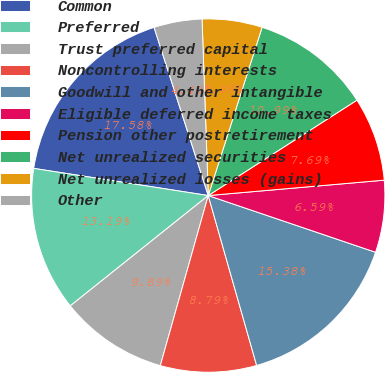<chart> <loc_0><loc_0><loc_500><loc_500><pie_chart><fcel>Common<fcel>Preferred<fcel>Trust preferred capital<fcel>Noncontrolling interests<fcel>Goodwill and other intangible<fcel>Eligible deferred income taxes<fcel>Pension other postretirement<fcel>Net unrealized securities<fcel>Net unrealized losses (gains)<fcel>Other<nl><fcel>17.58%<fcel>13.19%<fcel>9.89%<fcel>8.79%<fcel>15.38%<fcel>6.59%<fcel>7.69%<fcel>10.99%<fcel>5.49%<fcel>4.4%<nl></chart> 